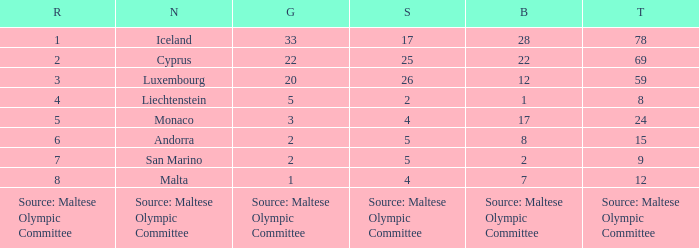How many bronze medals does the nation ranked number 1 have? 28.0. 